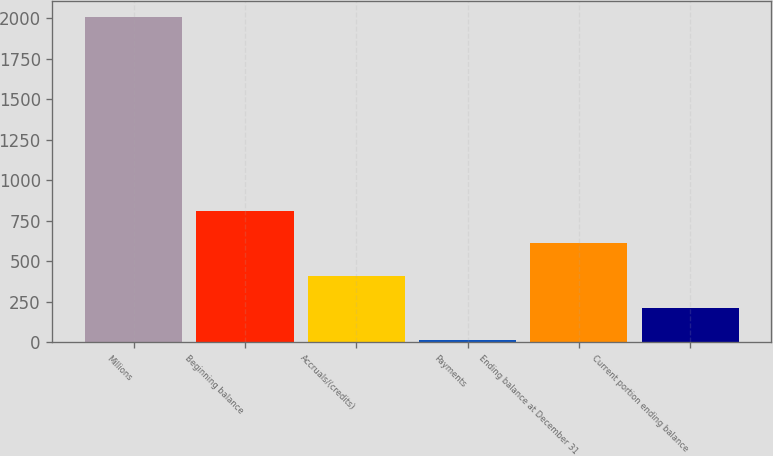Convert chart. <chart><loc_0><loc_0><loc_500><loc_500><bar_chart><fcel>Millions<fcel>Beginning balance<fcel>Accruals/(credits)<fcel>Payments<fcel>Ending balance at December 31<fcel>Current portion ending balance<nl><fcel>2008<fcel>809.2<fcel>409.6<fcel>10<fcel>609.4<fcel>209.8<nl></chart> 